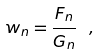Convert formula to latex. <formula><loc_0><loc_0><loc_500><loc_500>w _ { n } = \frac { F _ { n } } { G _ { n } } \ ,</formula> 